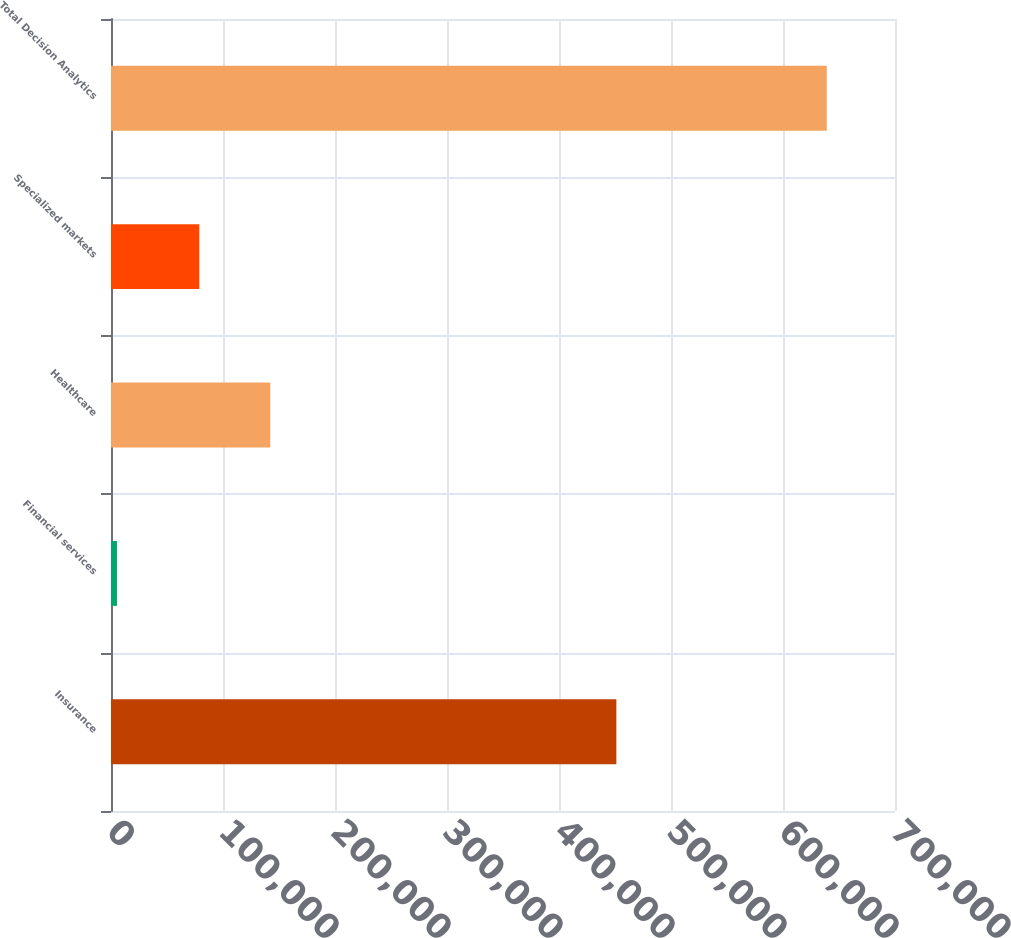Convert chart to OTSL. <chart><loc_0><loc_0><loc_500><loc_500><bar_chart><fcel>Insurance<fcel>Financial services<fcel>Healthcare<fcel>Specialized markets<fcel>Total Decision Analytics<nl><fcel>451216<fcel>5323<fcel>142217<fcel>78839<fcel>639100<nl></chart> 